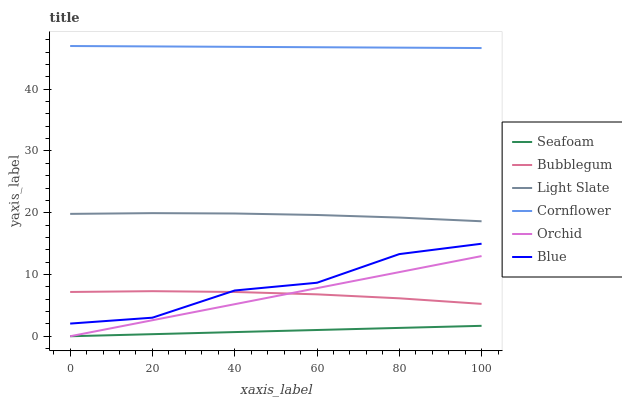Does Seafoam have the minimum area under the curve?
Answer yes or no. Yes. Does Cornflower have the maximum area under the curve?
Answer yes or no. Yes. Does Light Slate have the minimum area under the curve?
Answer yes or no. No. Does Light Slate have the maximum area under the curve?
Answer yes or no. No. Is Seafoam the smoothest?
Answer yes or no. Yes. Is Blue the roughest?
Answer yes or no. Yes. Is Cornflower the smoothest?
Answer yes or no. No. Is Cornflower the roughest?
Answer yes or no. No. Does Seafoam have the lowest value?
Answer yes or no. Yes. Does Light Slate have the lowest value?
Answer yes or no. No. Does Cornflower have the highest value?
Answer yes or no. Yes. Does Light Slate have the highest value?
Answer yes or no. No. Is Seafoam less than Cornflower?
Answer yes or no. Yes. Is Light Slate greater than Seafoam?
Answer yes or no. Yes. Does Blue intersect Bubblegum?
Answer yes or no. Yes. Is Blue less than Bubblegum?
Answer yes or no. No. Is Blue greater than Bubblegum?
Answer yes or no. No. Does Seafoam intersect Cornflower?
Answer yes or no. No. 